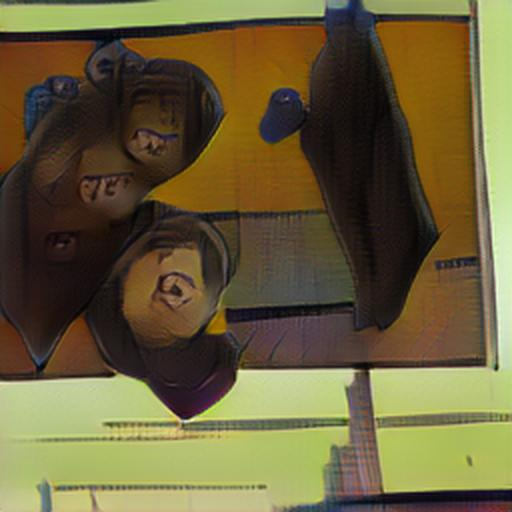What artistic techniques can be observed in this image? The image displays characteristics of a digitally altered or filtered photograph, showcasing a distortion effect that twists and stretches the elements within the frame. The technique gives the image a surreal, abstract quality, and could be seen as exploring themes of perception and reality. Additionally, the vibrant color palette and the overlay of patterns contribute to an overall impressionistic tone. 